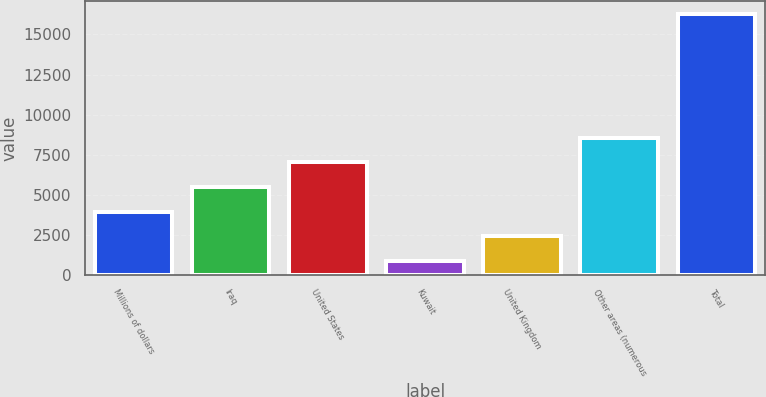Convert chart. <chart><loc_0><loc_0><loc_500><loc_500><bar_chart><fcel>Millions of dollars<fcel>Iraq<fcel>United States<fcel>Kuwait<fcel>United Kingdom<fcel>Other areas (numerous<fcel>Total<nl><fcel>3939<fcel>5480.5<fcel>7022<fcel>856<fcel>2397.5<fcel>8563.5<fcel>16271<nl></chart> 